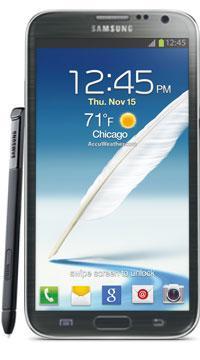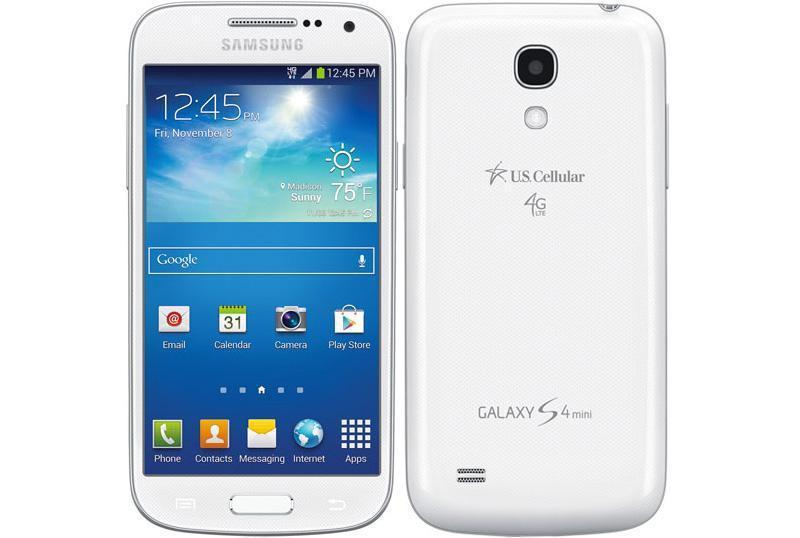The first image is the image on the left, the second image is the image on the right. Analyze the images presented: Is the assertion "A phone's side profile is in the right image." valid? Answer yes or no. No. 